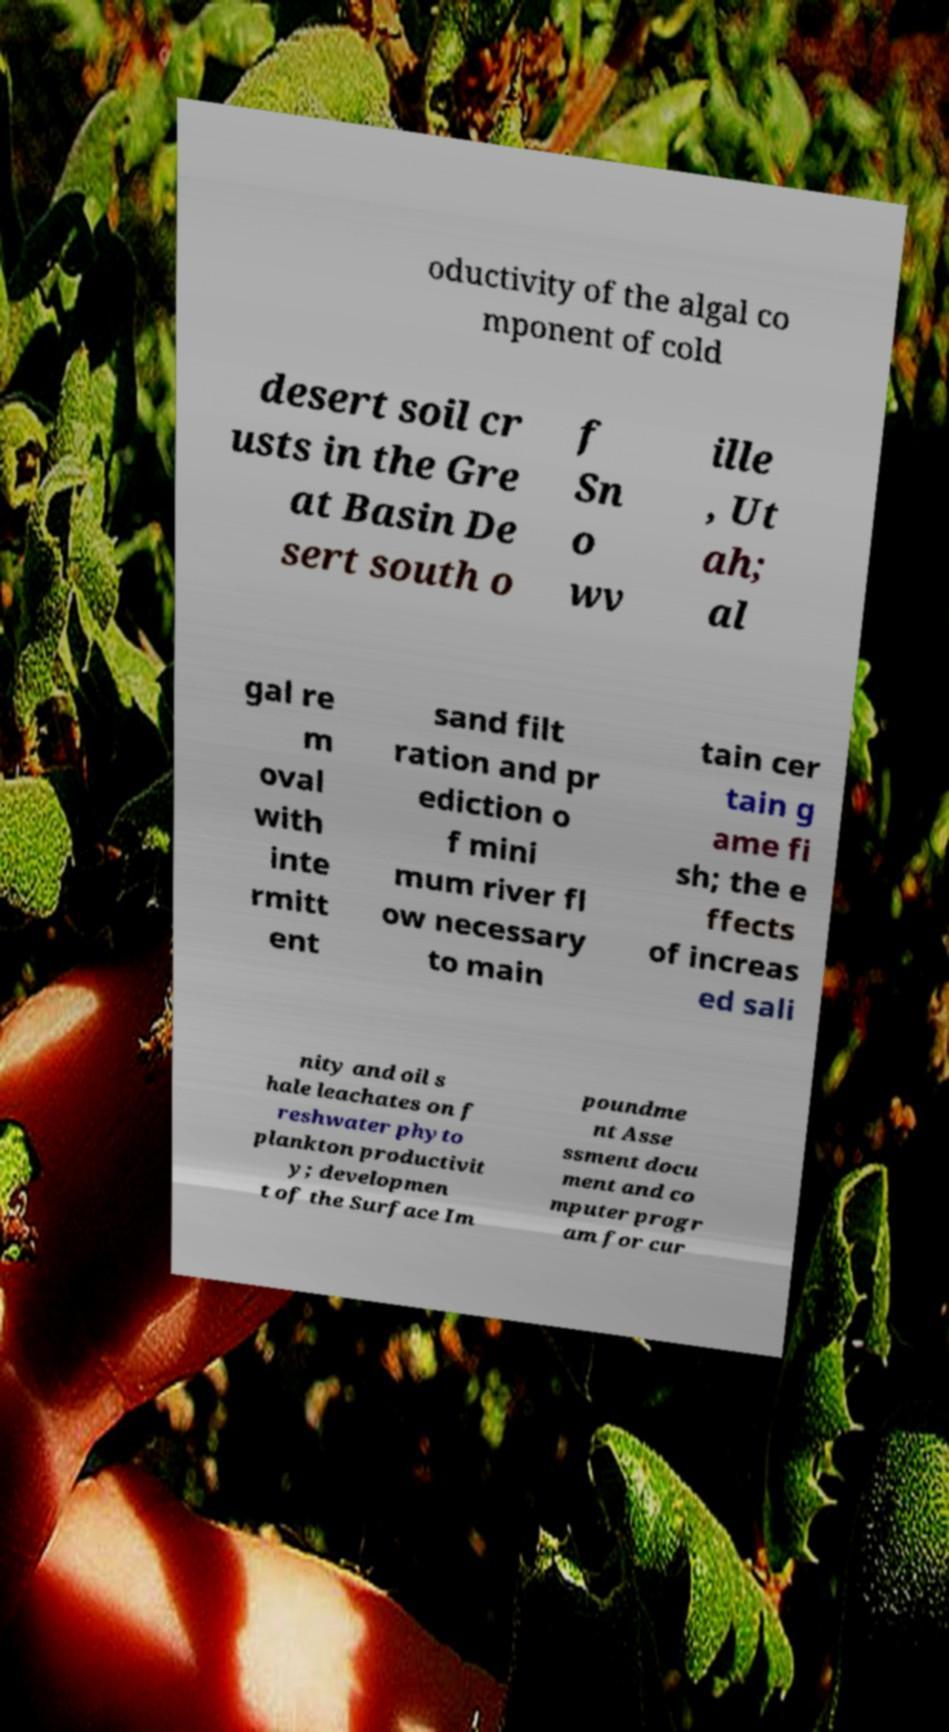I need the written content from this picture converted into text. Can you do that? oductivity of the algal co mponent of cold desert soil cr usts in the Gre at Basin De sert south o f Sn o wv ille , Ut ah; al gal re m oval with inte rmitt ent sand filt ration and pr ediction o f mini mum river fl ow necessary to main tain cer tain g ame fi sh; the e ffects of increas ed sali nity and oil s hale leachates on f reshwater phyto plankton productivit y; developmen t of the Surface Im poundme nt Asse ssment docu ment and co mputer progr am for cur 